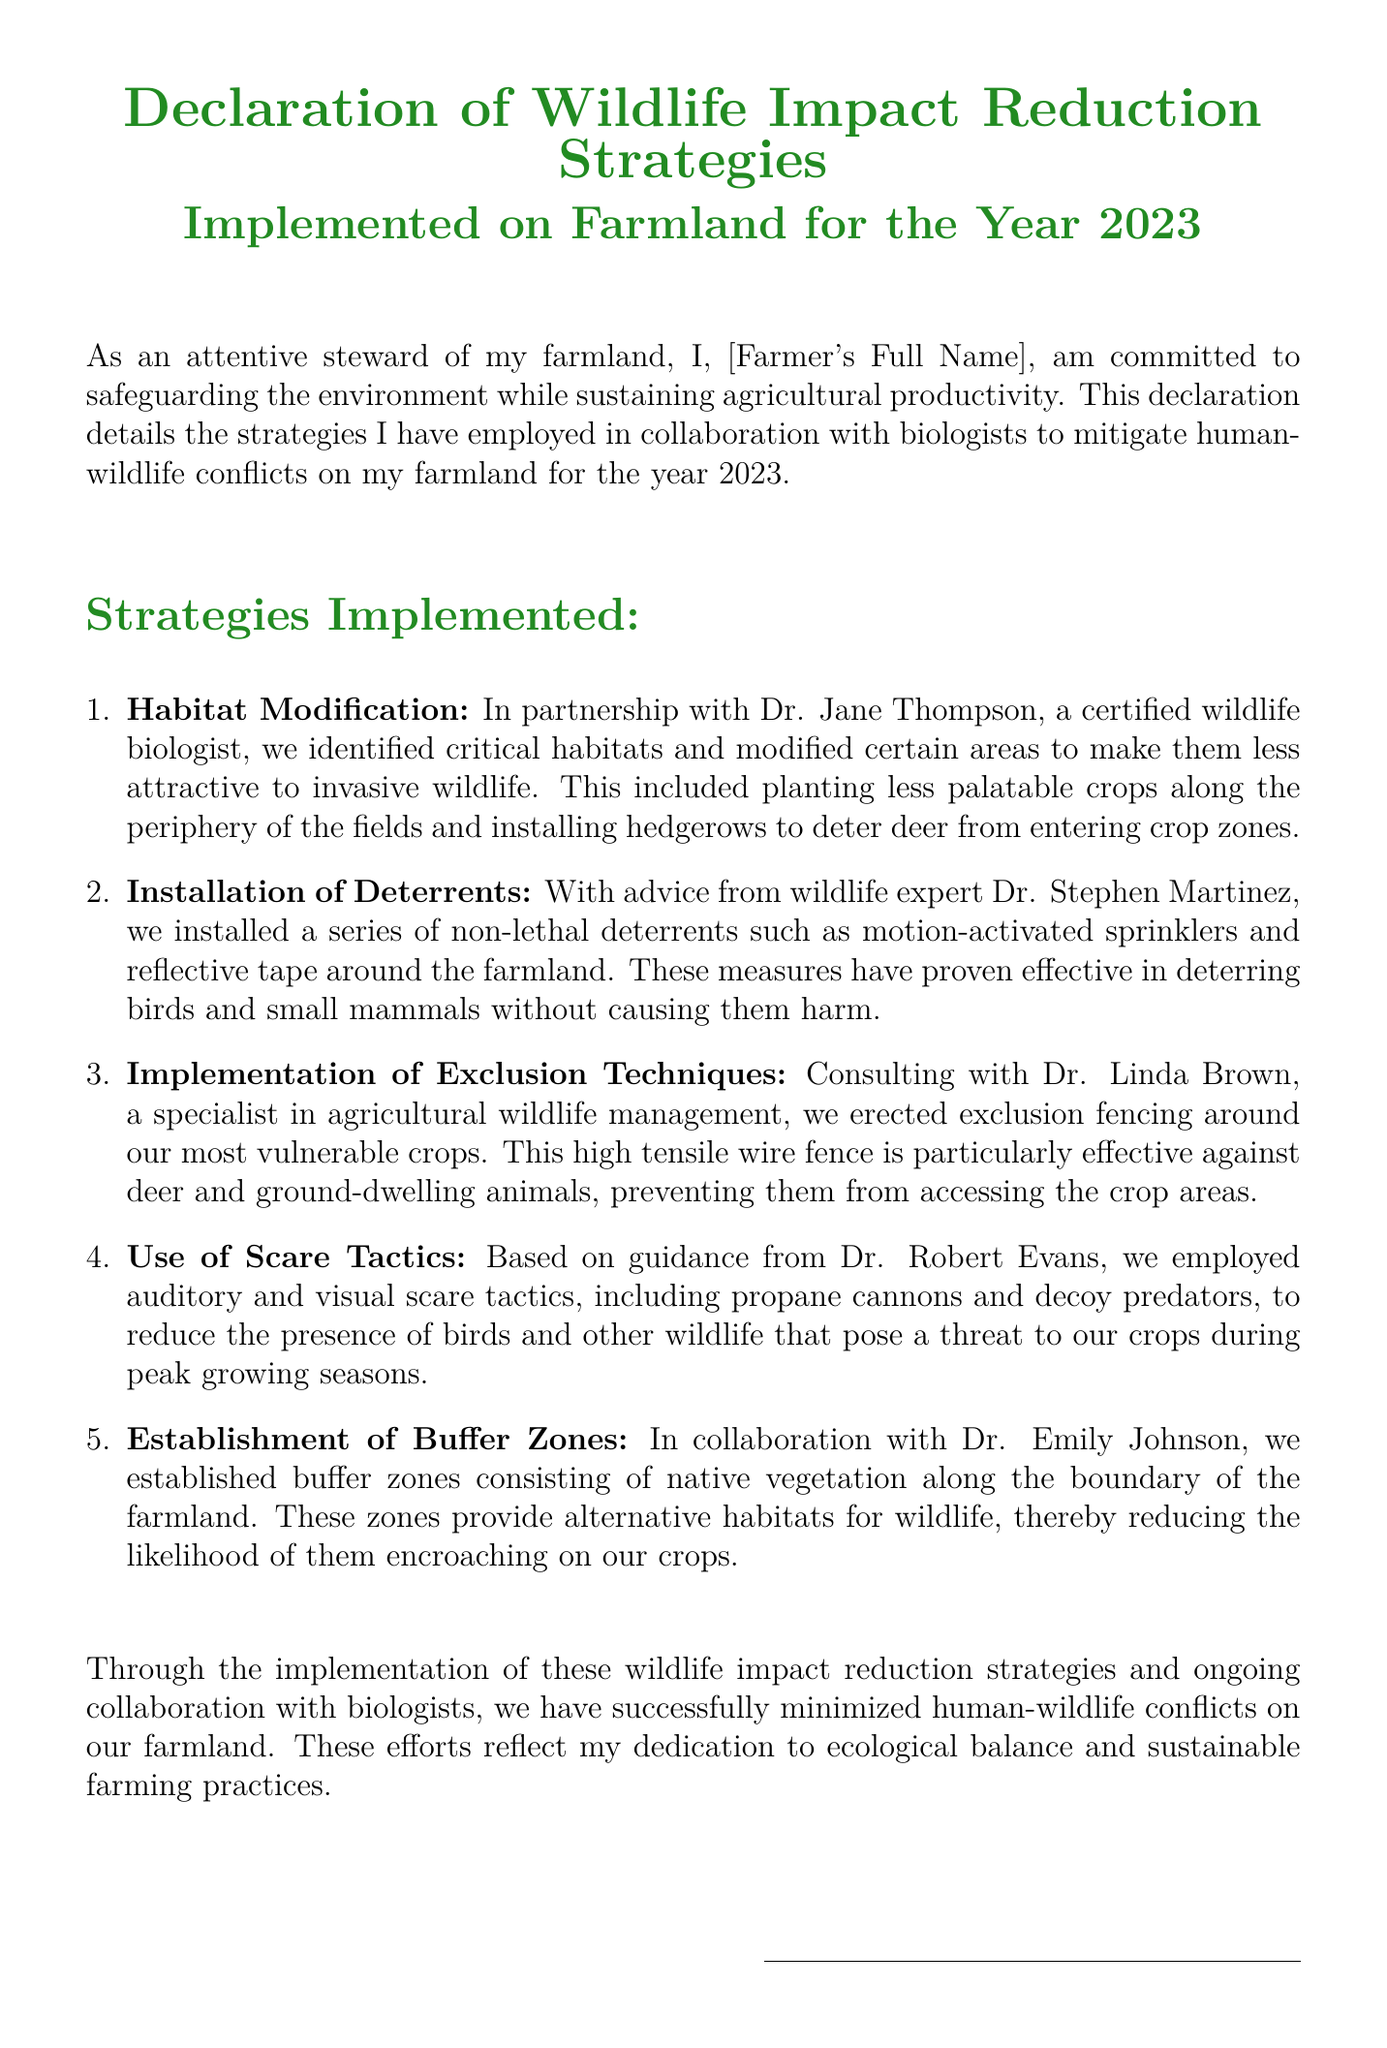What is the title of the document? The title of the document is presented at the top, specifying the declaration related to wildlife impact reduction strategies.
Answer: Declaration of Wildlife Impact Reduction Strategies Who collaborated with the farmer for habitat modification? The document lists a certified wildlife biologist who collaborated on this strategy.
Answer: Dr. Jane Thompson How many strategies were implemented according to the document? The number of strategies is outlined in the enumeration within the document.
Answer: Five What type of fencing was erected around vulnerable crops? The document specifies the type of fencing used to protect crops.
Answer: High tensile wire fence Which expert advised on the installation of deterrents? The document mentions the specific wildlife expert associated with the deterrent installation.
Answer: Dr. Stephen Martinez What is one of the scare tactics employed? The document details specific scare tactics utilized to deter wildlife, thus qualifies as an example.
Answer: Propane cannons What do established buffer zones consist of? The document explains the composition of the buffer zones created to aid wildlife management.
Answer: Native vegetation What is the year of the strategies implemented? The document specifies the year during which the wildlife impact reduction strategies were executed.
Answer: 2023 Who is responsible for signing the document? The document includes a placeholder for the signature of the individual affirming the declaration.
Answer: Farmer's Full Name 